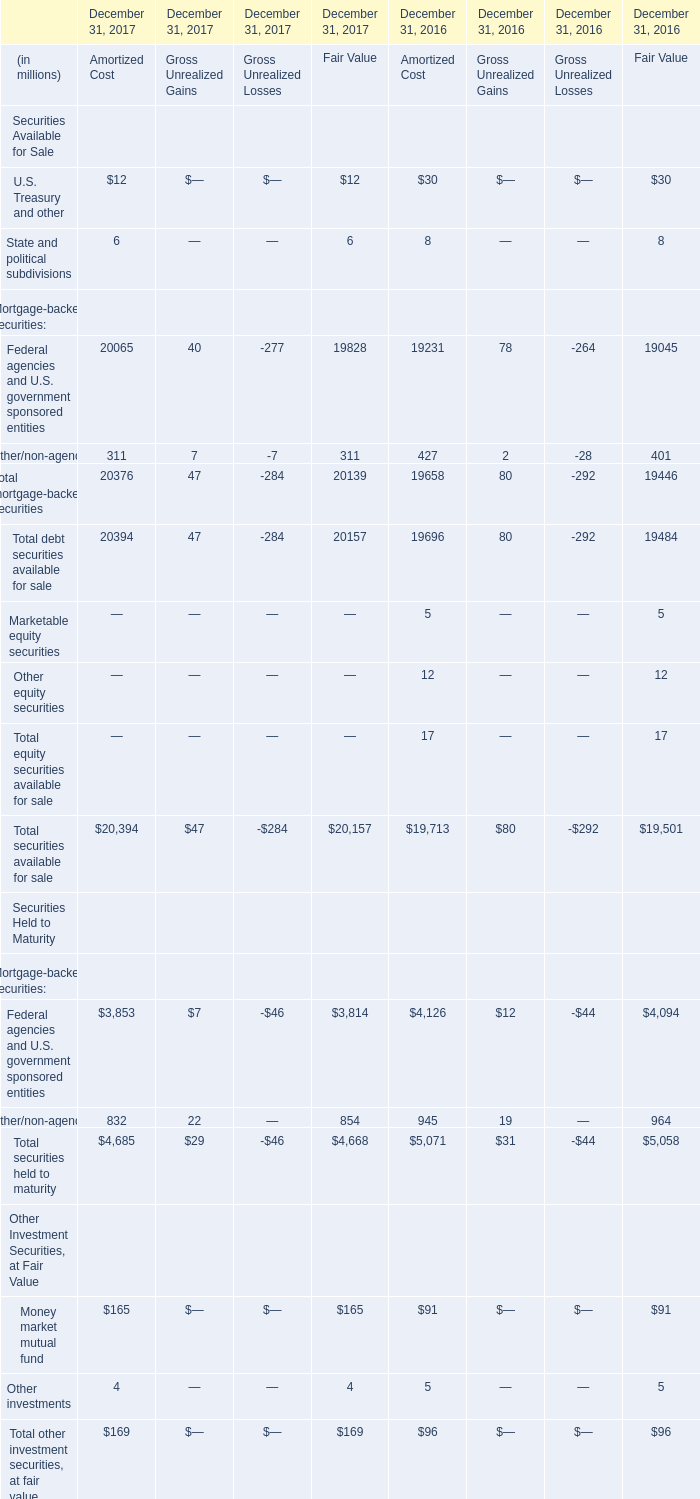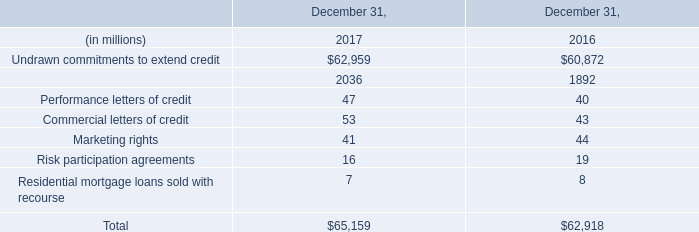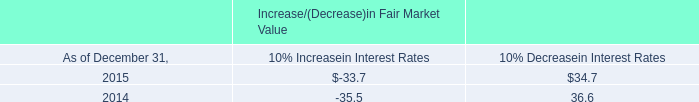what percent decrease for interest income occurred between 2014 and 2015? 
Computations: (((27.4 - 22.8) / 27.4) * 100)
Answer: 16.78832. 